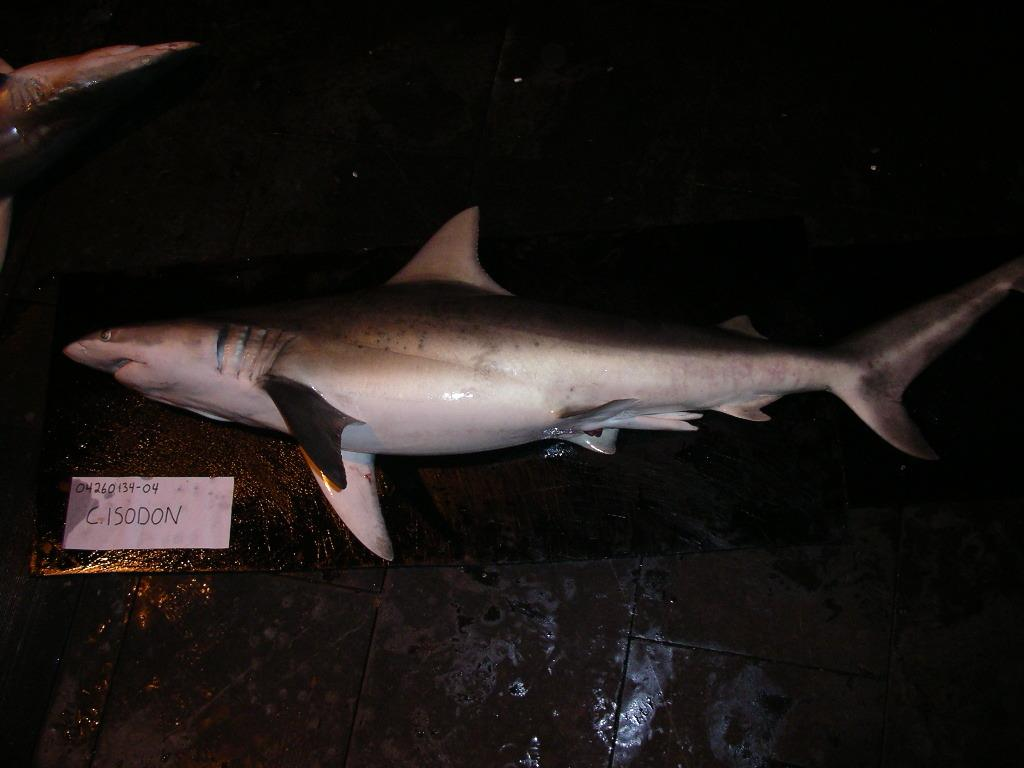What type of animals can be seen in the image? There are fishes in the image. What is the primary surface visible in the image? There is a floor visible in the image. Is there any additional covering on the floor? Yes, there is a mat on the floor in the image. What type of machine can be seen in the image? There is no machine present in the image; it features fishes, a floor, and a mat. What part of the human body is responsible for thinking in the image? There is no depiction of a human body or brain in the image. 